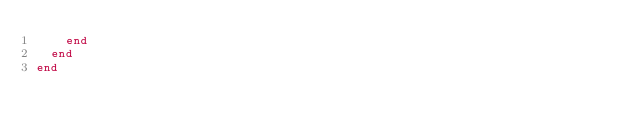<code> <loc_0><loc_0><loc_500><loc_500><_Ruby_>    end
  end
end
</code> 